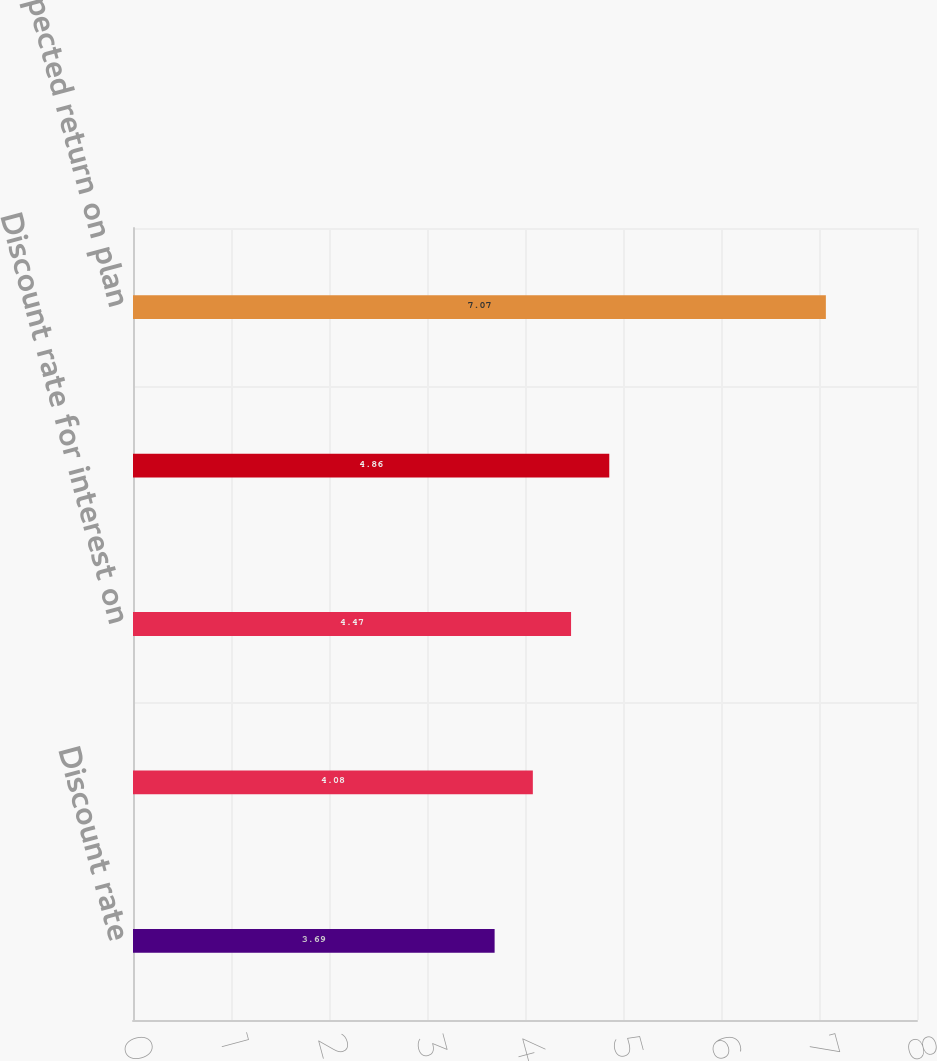<chart> <loc_0><loc_0><loc_500><loc_500><bar_chart><fcel>Discount rate<fcel>Discount rate for benefit<fcel>Discount rate for interest on<fcel>Discount rate for service cost<fcel>Expected return on plan<nl><fcel>3.69<fcel>4.08<fcel>4.47<fcel>4.86<fcel>7.07<nl></chart> 